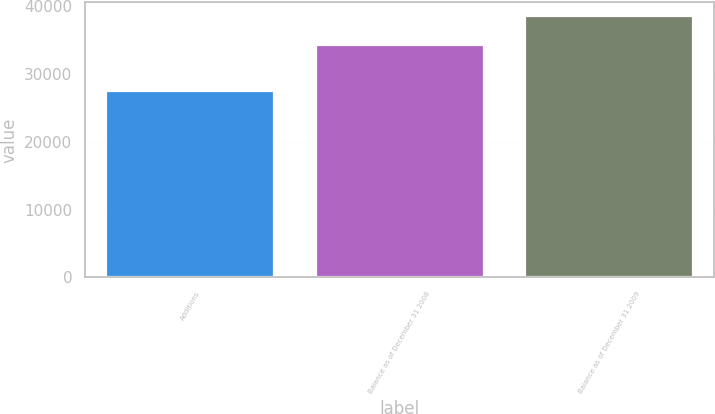Convert chart to OTSL. <chart><loc_0><loc_0><loc_500><loc_500><bar_chart><fcel>Additions<fcel>Balance as of December 31 2008<fcel>Balance as of December 31 2009<nl><fcel>27548<fcel>34353<fcel>38640<nl></chart> 